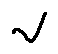Convert formula to latex. <formula><loc_0><loc_0><loc_500><loc_500>v</formula> 